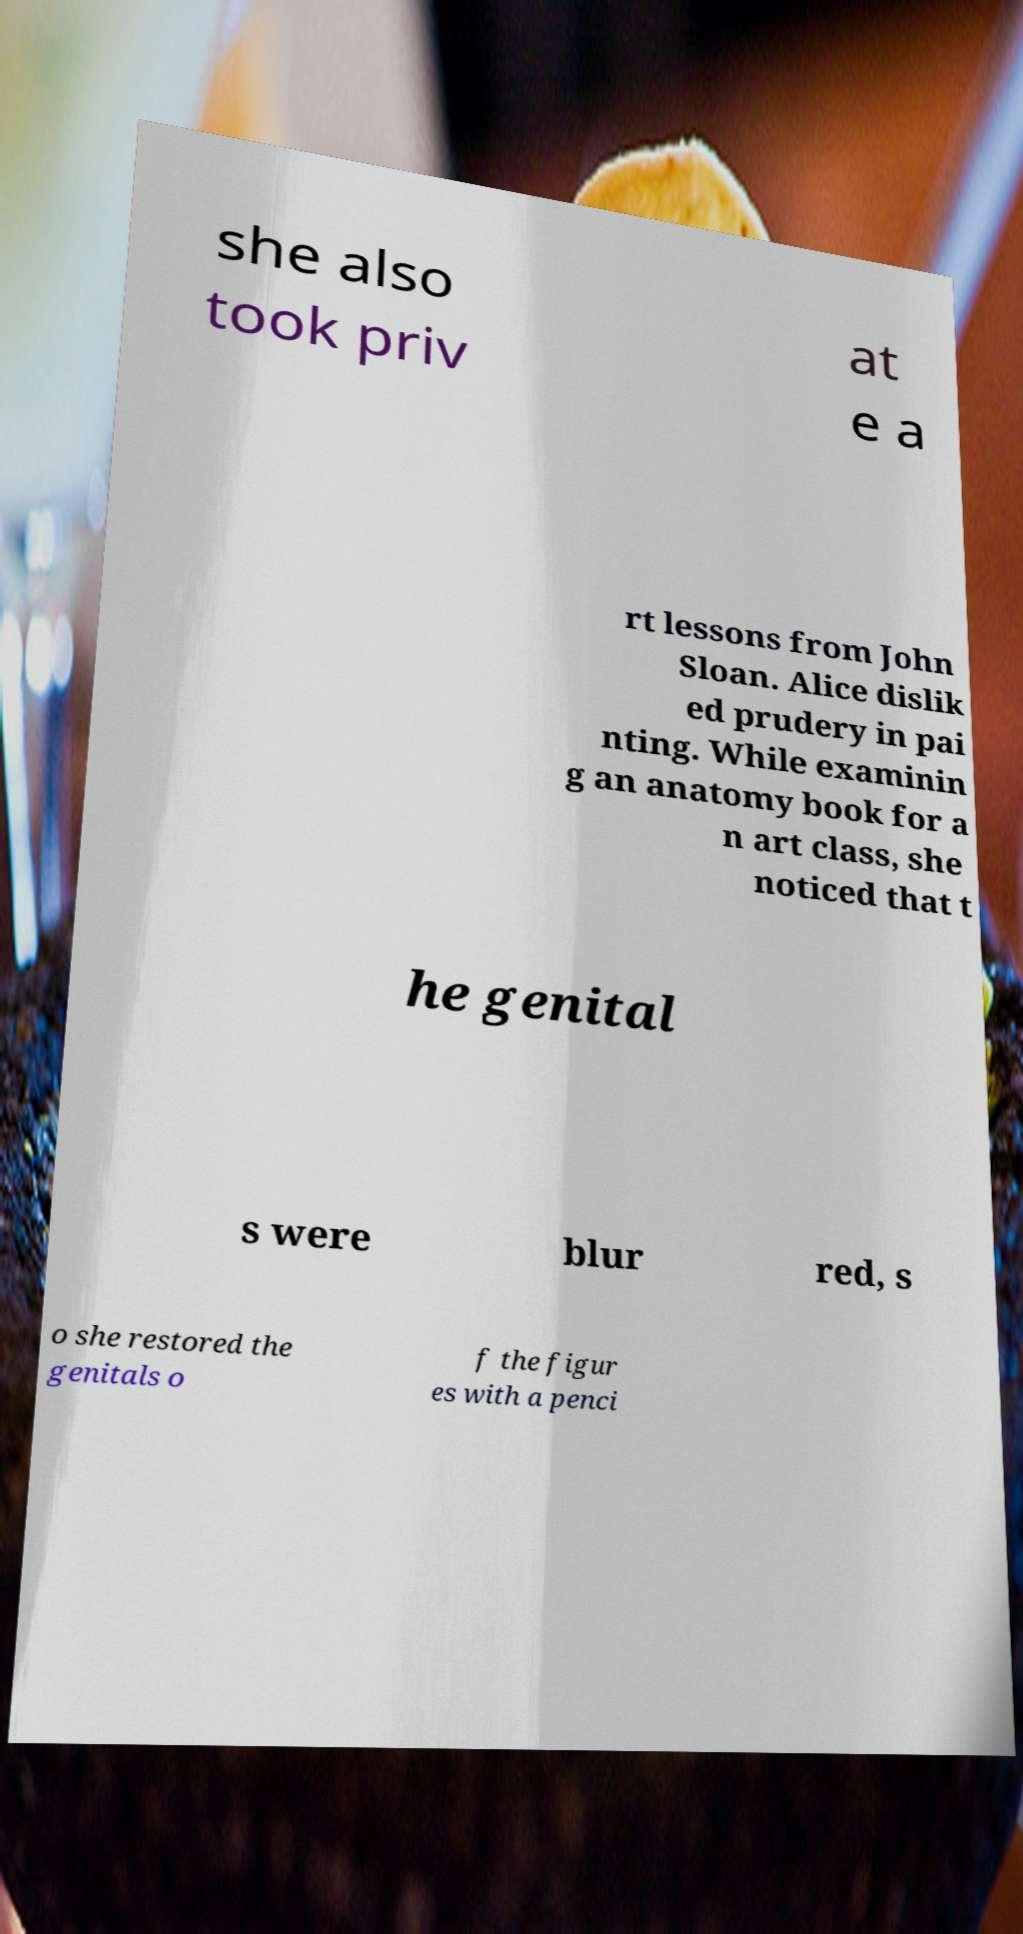What messages or text are displayed in this image? I need them in a readable, typed format. she also took priv at e a rt lessons from John Sloan. Alice dislik ed prudery in pai nting. While examinin g an anatomy book for a n art class, she noticed that t he genital s were blur red, s o she restored the genitals o f the figur es with a penci 